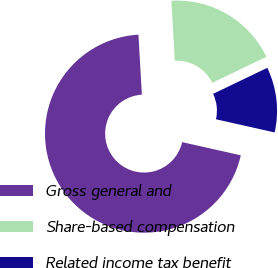Convert chart to OTSL. <chart><loc_0><loc_0><loc_500><loc_500><pie_chart><fcel>Gross general and<fcel>Share-based compensation<fcel>Related income tax benefit<nl><fcel>70.57%<fcel>18.79%<fcel>10.64%<nl></chart> 